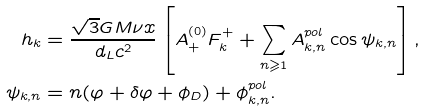<formula> <loc_0><loc_0><loc_500><loc_500>h _ { k } & = \frac { \sqrt { 3 } G M \nu x } { d _ { L } c ^ { 2 } } \left [ A _ { + } ^ { ( 0 ) } F _ { k } ^ { + } + \sum _ { n \geqslant 1 } A _ { k , n } ^ { p o l } \cos \psi _ { k , n } \right ] , \\ \psi _ { k , n } & = n ( \varphi + \delta \varphi + \phi _ { D } ) + \phi _ { k , n } ^ { p o l } .</formula> 